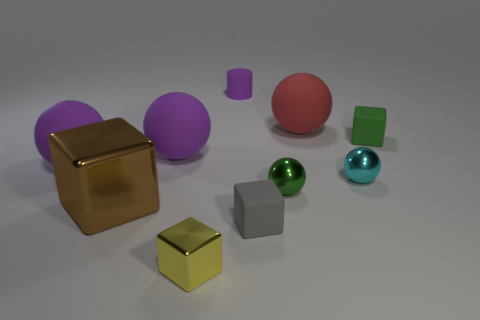Subtract all purple balls. How many balls are left? 3 Subtract all green spheres. How many spheres are left? 4 Subtract 3 blocks. How many blocks are left? 1 Subtract all cyan spheres. Subtract all green cylinders. How many spheres are left? 4 Subtract all purple cylinders. How many brown blocks are left? 1 Subtract all small green spheres. Subtract all gray objects. How many objects are left? 8 Add 2 brown objects. How many brown objects are left? 3 Add 10 red metallic balls. How many red metallic balls exist? 10 Subtract 1 green balls. How many objects are left? 9 Subtract all cubes. How many objects are left? 6 